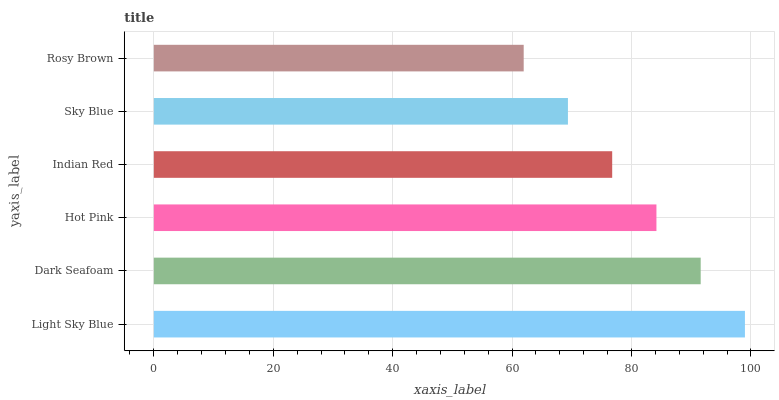Is Rosy Brown the minimum?
Answer yes or no. Yes. Is Light Sky Blue the maximum?
Answer yes or no. Yes. Is Dark Seafoam the minimum?
Answer yes or no. No. Is Dark Seafoam the maximum?
Answer yes or no. No. Is Light Sky Blue greater than Dark Seafoam?
Answer yes or no. Yes. Is Dark Seafoam less than Light Sky Blue?
Answer yes or no. Yes. Is Dark Seafoam greater than Light Sky Blue?
Answer yes or no. No. Is Light Sky Blue less than Dark Seafoam?
Answer yes or no. No. Is Hot Pink the high median?
Answer yes or no. Yes. Is Indian Red the low median?
Answer yes or no. Yes. Is Sky Blue the high median?
Answer yes or no. No. Is Rosy Brown the low median?
Answer yes or no. No. 